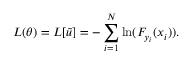Convert formula to latex. <formula><loc_0><loc_0><loc_500><loc_500>L ( \theta ) = L [ \tilde { u } ] = - \sum _ { i = 1 } ^ { N } \ln ( F _ { y _ { i } } ( x _ { i } ) ) .</formula> 